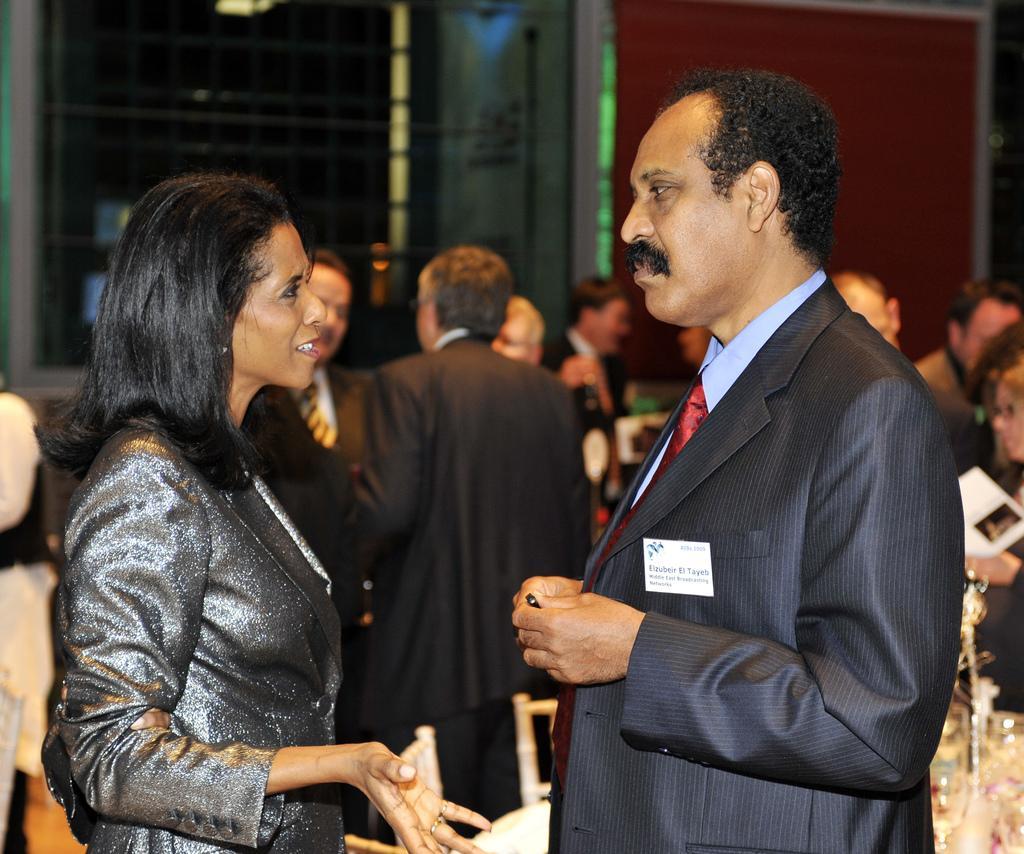In one or two sentences, can you explain what this image depicts? On the left side a woman is talking, she wore black color coat. On the right side a man is standing, he wore coat, tie, shirt and there are other people are standing other side of them. 